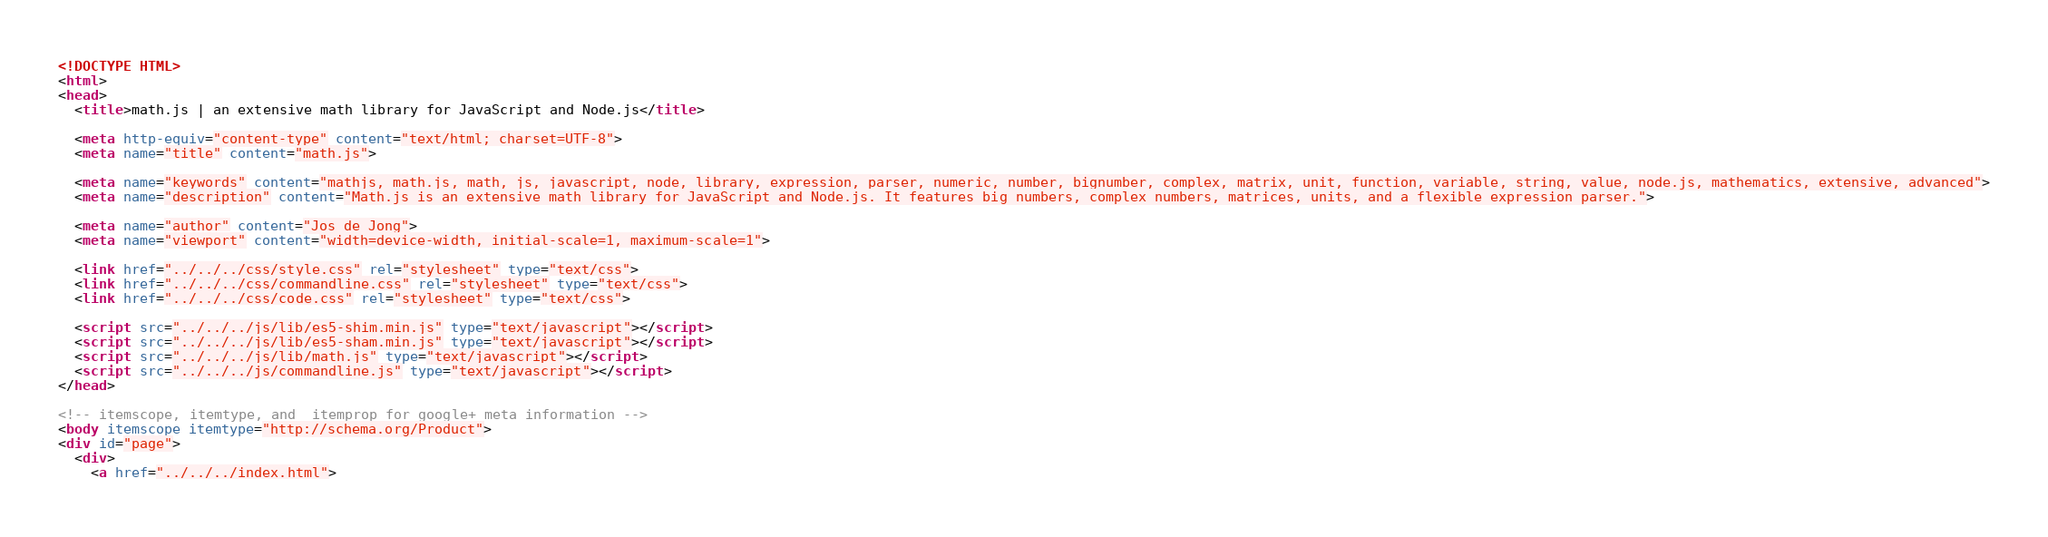Convert code to text. <code><loc_0><loc_0><loc_500><loc_500><_HTML_><!DOCTYPE HTML>
<html>
<head>
  <title>math.js | an extensive math library for JavaScript and Node.js</title>

  <meta http-equiv="content-type" content="text/html; charset=UTF-8">
  <meta name="title" content="math.js">

  <meta name="keywords" content="mathjs, math.js, math, js, javascript, node, library, expression, parser, numeric, number, bignumber, complex, matrix, unit, function, variable, string, value, node.js, mathematics, extensive, advanced">
  <meta name="description" content="Math.js is an extensive math library for JavaScript and Node.js. It features big numbers, complex numbers, matrices, units, and a flexible expression parser.">

  <meta name="author" content="Jos de Jong">
  <meta name="viewport" content="width=device-width, initial-scale=1, maximum-scale=1">

  <link href="../../../css/style.css" rel="stylesheet" type="text/css">
  <link href="../../../css/commandline.css" rel="stylesheet" type="text/css">
  <link href="../../../css/code.css" rel="stylesheet" type="text/css">

  <script src="../../../js/lib/es5-shim.min.js" type="text/javascript"></script>
  <script src="../../../js/lib/es5-sham.min.js" type="text/javascript"></script>
  <script src="../../../js/lib/math.js" type="text/javascript"></script>
  <script src="../../../js/commandline.js" type="text/javascript"></script>
</head>

<!-- itemscope, itemtype, and  itemprop for google+ meta information -->
<body itemscope itemtype="http://schema.org/Product">
<div id="page">
  <div>
    <a href="../../../index.html"></code> 